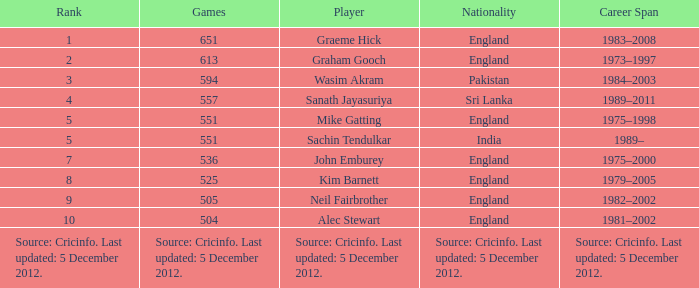What is the country of origin for the player who took part in 505 games? England. 